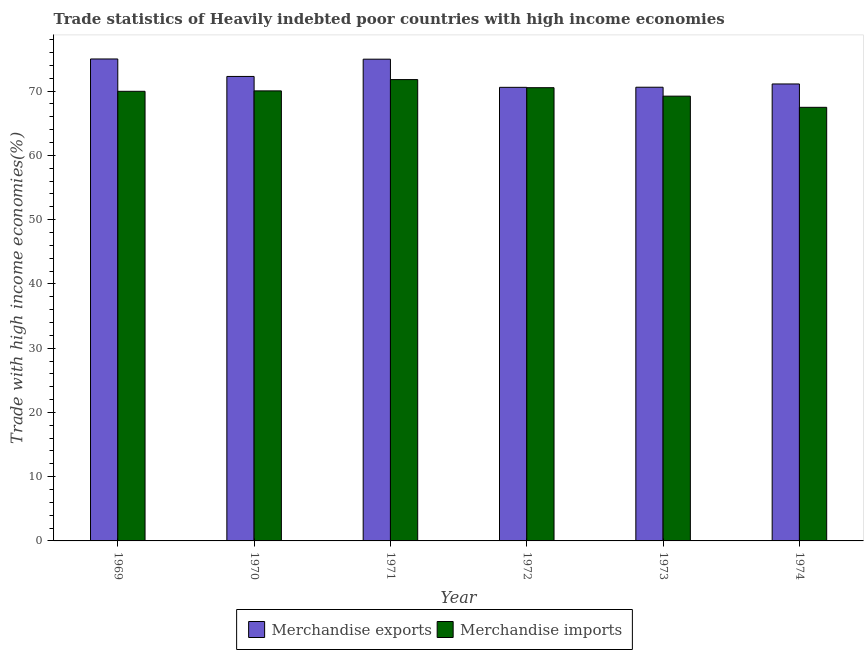How many groups of bars are there?
Your answer should be compact. 6. Are the number of bars per tick equal to the number of legend labels?
Ensure brevity in your answer.  Yes. How many bars are there on the 3rd tick from the left?
Ensure brevity in your answer.  2. What is the label of the 4th group of bars from the left?
Make the answer very short. 1972. In how many cases, is the number of bars for a given year not equal to the number of legend labels?
Offer a terse response. 0. What is the merchandise exports in 1973?
Keep it short and to the point. 70.61. Across all years, what is the maximum merchandise exports?
Ensure brevity in your answer.  75. Across all years, what is the minimum merchandise exports?
Provide a succinct answer. 70.59. In which year was the merchandise exports maximum?
Offer a very short reply. 1969. In which year was the merchandise imports minimum?
Give a very brief answer. 1974. What is the total merchandise exports in the graph?
Offer a very short reply. 434.57. What is the difference between the merchandise exports in 1969 and that in 1972?
Your response must be concise. 4.41. What is the difference between the merchandise exports in 1974 and the merchandise imports in 1973?
Your response must be concise. 0.51. What is the average merchandise exports per year?
Give a very brief answer. 72.43. In the year 1971, what is the difference between the merchandise exports and merchandise imports?
Make the answer very short. 0. In how many years, is the merchandise exports greater than 68 %?
Your answer should be very brief. 6. What is the ratio of the merchandise exports in 1971 to that in 1974?
Your answer should be compact. 1.05. Is the merchandise imports in 1972 less than that in 1974?
Keep it short and to the point. No. What is the difference between the highest and the second highest merchandise imports?
Your response must be concise. 1.26. What is the difference between the highest and the lowest merchandise imports?
Offer a very short reply. 4.31. In how many years, is the merchandise exports greater than the average merchandise exports taken over all years?
Provide a succinct answer. 2. Is the sum of the merchandise exports in 1970 and 1974 greater than the maximum merchandise imports across all years?
Provide a short and direct response. Yes. What does the 2nd bar from the left in 1970 represents?
Offer a very short reply. Merchandise imports. Are all the bars in the graph horizontal?
Provide a short and direct response. No. Where does the legend appear in the graph?
Keep it short and to the point. Bottom center. How many legend labels are there?
Provide a succinct answer. 2. What is the title of the graph?
Make the answer very short. Trade statistics of Heavily indebted poor countries with high income economies. Does "RDB nonconcessional" appear as one of the legend labels in the graph?
Offer a terse response. No. What is the label or title of the Y-axis?
Keep it short and to the point. Trade with high income economies(%). What is the Trade with high income economies(%) in Merchandise exports in 1969?
Ensure brevity in your answer.  75. What is the Trade with high income economies(%) of Merchandise imports in 1969?
Give a very brief answer. 69.97. What is the Trade with high income economies(%) in Merchandise exports in 1970?
Provide a short and direct response. 72.28. What is the Trade with high income economies(%) in Merchandise imports in 1970?
Offer a terse response. 70.04. What is the Trade with high income economies(%) of Merchandise exports in 1971?
Keep it short and to the point. 74.97. What is the Trade with high income economies(%) in Merchandise imports in 1971?
Offer a terse response. 71.8. What is the Trade with high income economies(%) of Merchandise exports in 1972?
Provide a short and direct response. 70.59. What is the Trade with high income economies(%) in Merchandise imports in 1972?
Keep it short and to the point. 70.53. What is the Trade with high income economies(%) of Merchandise exports in 1973?
Give a very brief answer. 70.61. What is the Trade with high income economies(%) in Merchandise imports in 1973?
Keep it short and to the point. 69.22. What is the Trade with high income economies(%) in Merchandise exports in 1974?
Give a very brief answer. 71.11. What is the Trade with high income economies(%) of Merchandise imports in 1974?
Offer a terse response. 67.48. Across all years, what is the maximum Trade with high income economies(%) in Merchandise exports?
Make the answer very short. 75. Across all years, what is the maximum Trade with high income economies(%) in Merchandise imports?
Your answer should be very brief. 71.8. Across all years, what is the minimum Trade with high income economies(%) of Merchandise exports?
Ensure brevity in your answer.  70.59. Across all years, what is the minimum Trade with high income economies(%) of Merchandise imports?
Provide a short and direct response. 67.48. What is the total Trade with high income economies(%) in Merchandise exports in the graph?
Give a very brief answer. 434.57. What is the total Trade with high income economies(%) of Merchandise imports in the graph?
Your response must be concise. 419.04. What is the difference between the Trade with high income economies(%) of Merchandise exports in 1969 and that in 1970?
Provide a succinct answer. 2.72. What is the difference between the Trade with high income economies(%) of Merchandise imports in 1969 and that in 1970?
Ensure brevity in your answer.  -0.07. What is the difference between the Trade with high income economies(%) in Merchandise exports in 1969 and that in 1971?
Your answer should be very brief. 0.03. What is the difference between the Trade with high income economies(%) in Merchandise imports in 1969 and that in 1971?
Provide a short and direct response. -1.82. What is the difference between the Trade with high income economies(%) in Merchandise exports in 1969 and that in 1972?
Offer a very short reply. 4.41. What is the difference between the Trade with high income economies(%) of Merchandise imports in 1969 and that in 1972?
Give a very brief answer. -0.56. What is the difference between the Trade with high income economies(%) in Merchandise exports in 1969 and that in 1973?
Ensure brevity in your answer.  4.4. What is the difference between the Trade with high income economies(%) in Merchandise imports in 1969 and that in 1973?
Offer a terse response. 0.75. What is the difference between the Trade with high income economies(%) of Merchandise exports in 1969 and that in 1974?
Provide a short and direct response. 3.89. What is the difference between the Trade with high income economies(%) in Merchandise imports in 1969 and that in 1974?
Your response must be concise. 2.49. What is the difference between the Trade with high income economies(%) in Merchandise exports in 1970 and that in 1971?
Your response must be concise. -2.69. What is the difference between the Trade with high income economies(%) in Merchandise imports in 1970 and that in 1971?
Keep it short and to the point. -1.76. What is the difference between the Trade with high income economies(%) in Merchandise exports in 1970 and that in 1972?
Give a very brief answer. 1.69. What is the difference between the Trade with high income economies(%) of Merchandise imports in 1970 and that in 1972?
Keep it short and to the point. -0.5. What is the difference between the Trade with high income economies(%) of Merchandise exports in 1970 and that in 1973?
Provide a short and direct response. 1.68. What is the difference between the Trade with high income economies(%) in Merchandise imports in 1970 and that in 1973?
Your answer should be very brief. 0.82. What is the difference between the Trade with high income economies(%) in Merchandise exports in 1970 and that in 1974?
Your response must be concise. 1.17. What is the difference between the Trade with high income economies(%) of Merchandise imports in 1970 and that in 1974?
Offer a terse response. 2.56. What is the difference between the Trade with high income economies(%) in Merchandise exports in 1971 and that in 1972?
Provide a succinct answer. 4.38. What is the difference between the Trade with high income economies(%) of Merchandise imports in 1971 and that in 1972?
Offer a terse response. 1.26. What is the difference between the Trade with high income economies(%) in Merchandise exports in 1971 and that in 1973?
Offer a terse response. 4.37. What is the difference between the Trade with high income economies(%) of Merchandise imports in 1971 and that in 1973?
Offer a terse response. 2.58. What is the difference between the Trade with high income economies(%) of Merchandise exports in 1971 and that in 1974?
Your answer should be compact. 3.86. What is the difference between the Trade with high income economies(%) of Merchandise imports in 1971 and that in 1974?
Make the answer very short. 4.31. What is the difference between the Trade with high income economies(%) of Merchandise exports in 1972 and that in 1973?
Your answer should be compact. -0.01. What is the difference between the Trade with high income economies(%) in Merchandise imports in 1972 and that in 1973?
Your answer should be compact. 1.31. What is the difference between the Trade with high income economies(%) in Merchandise exports in 1972 and that in 1974?
Your answer should be compact. -0.52. What is the difference between the Trade with high income economies(%) of Merchandise imports in 1972 and that in 1974?
Offer a very short reply. 3.05. What is the difference between the Trade with high income economies(%) in Merchandise exports in 1973 and that in 1974?
Provide a short and direct response. -0.51. What is the difference between the Trade with high income economies(%) in Merchandise imports in 1973 and that in 1974?
Your answer should be very brief. 1.74. What is the difference between the Trade with high income economies(%) of Merchandise exports in 1969 and the Trade with high income economies(%) of Merchandise imports in 1970?
Give a very brief answer. 4.97. What is the difference between the Trade with high income economies(%) of Merchandise exports in 1969 and the Trade with high income economies(%) of Merchandise imports in 1971?
Your answer should be very brief. 3.21. What is the difference between the Trade with high income economies(%) in Merchandise exports in 1969 and the Trade with high income economies(%) in Merchandise imports in 1972?
Your answer should be very brief. 4.47. What is the difference between the Trade with high income economies(%) of Merchandise exports in 1969 and the Trade with high income economies(%) of Merchandise imports in 1973?
Your answer should be compact. 5.78. What is the difference between the Trade with high income economies(%) of Merchandise exports in 1969 and the Trade with high income economies(%) of Merchandise imports in 1974?
Offer a terse response. 7.52. What is the difference between the Trade with high income economies(%) of Merchandise exports in 1970 and the Trade with high income economies(%) of Merchandise imports in 1971?
Offer a very short reply. 0.49. What is the difference between the Trade with high income economies(%) of Merchandise exports in 1970 and the Trade with high income economies(%) of Merchandise imports in 1972?
Make the answer very short. 1.75. What is the difference between the Trade with high income economies(%) of Merchandise exports in 1970 and the Trade with high income economies(%) of Merchandise imports in 1973?
Offer a terse response. 3.06. What is the difference between the Trade with high income economies(%) of Merchandise exports in 1970 and the Trade with high income economies(%) of Merchandise imports in 1974?
Your answer should be very brief. 4.8. What is the difference between the Trade with high income economies(%) of Merchandise exports in 1971 and the Trade with high income economies(%) of Merchandise imports in 1972?
Provide a succinct answer. 4.44. What is the difference between the Trade with high income economies(%) of Merchandise exports in 1971 and the Trade with high income economies(%) of Merchandise imports in 1973?
Give a very brief answer. 5.75. What is the difference between the Trade with high income economies(%) in Merchandise exports in 1971 and the Trade with high income economies(%) in Merchandise imports in 1974?
Give a very brief answer. 7.49. What is the difference between the Trade with high income economies(%) in Merchandise exports in 1972 and the Trade with high income economies(%) in Merchandise imports in 1973?
Make the answer very short. 1.37. What is the difference between the Trade with high income economies(%) of Merchandise exports in 1972 and the Trade with high income economies(%) of Merchandise imports in 1974?
Your answer should be compact. 3.11. What is the difference between the Trade with high income economies(%) of Merchandise exports in 1973 and the Trade with high income economies(%) of Merchandise imports in 1974?
Provide a succinct answer. 3.13. What is the average Trade with high income economies(%) in Merchandise exports per year?
Ensure brevity in your answer.  72.43. What is the average Trade with high income economies(%) in Merchandise imports per year?
Offer a terse response. 69.84. In the year 1969, what is the difference between the Trade with high income economies(%) in Merchandise exports and Trade with high income economies(%) in Merchandise imports?
Your answer should be compact. 5.03. In the year 1970, what is the difference between the Trade with high income economies(%) in Merchandise exports and Trade with high income economies(%) in Merchandise imports?
Your response must be concise. 2.25. In the year 1971, what is the difference between the Trade with high income economies(%) in Merchandise exports and Trade with high income economies(%) in Merchandise imports?
Provide a succinct answer. 3.18. In the year 1972, what is the difference between the Trade with high income economies(%) of Merchandise exports and Trade with high income economies(%) of Merchandise imports?
Your answer should be compact. 0.06. In the year 1973, what is the difference between the Trade with high income economies(%) in Merchandise exports and Trade with high income economies(%) in Merchandise imports?
Provide a succinct answer. 1.39. In the year 1974, what is the difference between the Trade with high income economies(%) in Merchandise exports and Trade with high income economies(%) in Merchandise imports?
Give a very brief answer. 3.63. What is the ratio of the Trade with high income economies(%) in Merchandise exports in 1969 to that in 1970?
Your response must be concise. 1.04. What is the ratio of the Trade with high income economies(%) of Merchandise imports in 1969 to that in 1971?
Your answer should be compact. 0.97. What is the ratio of the Trade with high income economies(%) of Merchandise exports in 1969 to that in 1972?
Give a very brief answer. 1.06. What is the ratio of the Trade with high income economies(%) of Merchandise exports in 1969 to that in 1973?
Your response must be concise. 1.06. What is the ratio of the Trade with high income economies(%) in Merchandise imports in 1969 to that in 1973?
Offer a very short reply. 1.01. What is the ratio of the Trade with high income economies(%) in Merchandise exports in 1969 to that in 1974?
Your answer should be very brief. 1.05. What is the ratio of the Trade with high income economies(%) of Merchandise imports in 1969 to that in 1974?
Your answer should be compact. 1.04. What is the ratio of the Trade with high income economies(%) of Merchandise exports in 1970 to that in 1971?
Your answer should be very brief. 0.96. What is the ratio of the Trade with high income economies(%) of Merchandise imports in 1970 to that in 1971?
Your answer should be compact. 0.98. What is the ratio of the Trade with high income economies(%) of Merchandise exports in 1970 to that in 1972?
Offer a terse response. 1.02. What is the ratio of the Trade with high income economies(%) in Merchandise exports in 1970 to that in 1973?
Ensure brevity in your answer.  1.02. What is the ratio of the Trade with high income economies(%) in Merchandise imports in 1970 to that in 1973?
Your response must be concise. 1.01. What is the ratio of the Trade with high income economies(%) of Merchandise exports in 1970 to that in 1974?
Provide a succinct answer. 1.02. What is the ratio of the Trade with high income economies(%) in Merchandise imports in 1970 to that in 1974?
Offer a terse response. 1.04. What is the ratio of the Trade with high income economies(%) of Merchandise exports in 1971 to that in 1972?
Ensure brevity in your answer.  1.06. What is the ratio of the Trade with high income economies(%) of Merchandise imports in 1971 to that in 1972?
Provide a succinct answer. 1.02. What is the ratio of the Trade with high income economies(%) of Merchandise exports in 1971 to that in 1973?
Provide a short and direct response. 1.06. What is the ratio of the Trade with high income economies(%) of Merchandise imports in 1971 to that in 1973?
Offer a very short reply. 1.04. What is the ratio of the Trade with high income economies(%) of Merchandise exports in 1971 to that in 1974?
Your response must be concise. 1.05. What is the ratio of the Trade with high income economies(%) of Merchandise imports in 1971 to that in 1974?
Make the answer very short. 1.06. What is the ratio of the Trade with high income economies(%) in Merchandise exports in 1972 to that in 1973?
Ensure brevity in your answer.  1. What is the ratio of the Trade with high income economies(%) in Merchandise imports in 1972 to that in 1973?
Ensure brevity in your answer.  1.02. What is the ratio of the Trade with high income economies(%) of Merchandise exports in 1972 to that in 1974?
Your response must be concise. 0.99. What is the ratio of the Trade with high income economies(%) in Merchandise imports in 1972 to that in 1974?
Your response must be concise. 1.05. What is the ratio of the Trade with high income economies(%) in Merchandise imports in 1973 to that in 1974?
Offer a very short reply. 1.03. What is the difference between the highest and the second highest Trade with high income economies(%) in Merchandise exports?
Ensure brevity in your answer.  0.03. What is the difference between the highest and the second highest Trade with high income economies(%) in Merchandise imports?
Your answer should be very brief. 1.26. What is the difference between the highest and the lowest Trade with high income economies(%) in Merchandise exports?
Your answer should be very brief. 4.41. What is the difference between the highest and the lowest Trade with high income economies(%) of Merchandise imports?
Give a very brief answer. 4.31. 